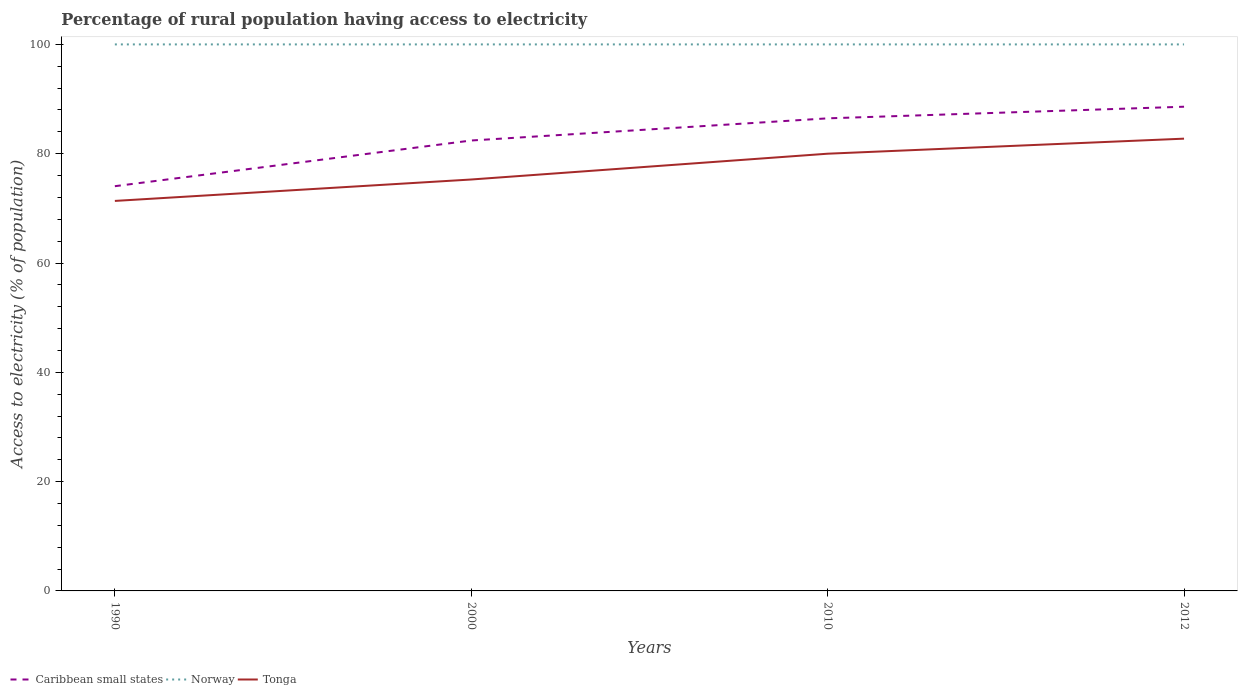Is the number of lines equal to the number of legend labels?
Ensure brevity in your answer.  Yes. Across all years, what is the maximum percentage of rural population having access to electricity in Norway?
Your answer should be very brief. 100. In which year was the percentage of rural population having access to electricity in Norway maximum?
Your response must be concise. 1990. What is the total percentage of rural population having access to electricity in Tonga in the graph?
Give a very brief answer. -2.75. What is the difference between the highest and the second highest percentage of rural population having access to electricity in Norway?
Offer a terse response. 0. What is the difference between the highest and the lowest percentage of rural population having access to electricity in Caribbean small states?
Ensure brevity in your answer.  2. Does the graph contain grids?
Give a very brief answer. No. How many legend labels are there?
Your response must be concise. 3. How are the legend labels stacked?
Provide a short and direct response. Horizontal. What is the title of the graph?
Offer a very short reply. Percentage of rural population having access to electricity. Does "Chad" appear as one of the legend labels in the graph?
Offer a terse response. No. What is the label or title of the Y-axis?
Your answer should be compact. Access to electricity (% of population). What is the Access to electricity (% of population) of Caribbean small states in 1990?
Offer a very short reply. 74.06. What is the Access to electricity (% of population) in Tonga in 1990?
Your answer should be very brief. 71.36. What is the Access to electricity (% of population) of Caribbean small states in 2000?
Your answer should be compact. 82.42. What is the Access to electricity (% of population) of Norway in 2000?
Provide a succinct answer. 100. What is the Access to electricity (% of population) in Tonga in 2000?
Your response must be concise. 75.28. What is the Access to electricity (% of population) of Caribbean small states in 2010?
Offer a terse response. 86.47. What is the Access to electricity (% of population) of Norway in 2010?
Your answer should be very brief. 100. What is the Access to electricity (% of population) of Caribbean small states in 2012?
Your answer should be very brief. 88.6. What is the Access to electricity (% of population) in Tonga in 2012?
Your answer should be compact. 82.75. Across all years, what is the maximum Access to electricity (% of population) in Caribbean small states?
Give a very brief answer. 88.6. Across all years, what is the maximum Access to electricity (% of population) of Norway?
Make the answer very short. 100. Across all years, what is the maximum Access to electricity (% of population) of Tonga?
Provide a succinct answer. 82.75. Across all years, what is the minimum Access to electricity (% of population) of Caribbean small states?
Your answer should be very brief. 74.06. Across all years, what is the minimum Access to electricity (% of population) of Norway?
Offer a terse response. 100. Across all years, what is the minimum Access to electricity (% of population) in Tonga?
Give a very brief answer. 71.36. What is the total Access to electricity (% of population) in Caribbean small states in the graph?
Provide a succinct answer. 331.54. What is the total Access to electricity (% of population) of Tonga in the graph?
Make the answer very short. 309.4. What is the difference between the Access to electricity (% of population) in Caribbean small states in 1990 and that in 2000?
Your answer should be very brief. -8.36. What is the difference between the Access to electricity (% of population) of Norway in 1990 and that in 2000?
Ensure brevity in your answer.  0. What is the difference between the Access to electricity (% of population) of Tonga in 1990 and that in 2000?
Ensure brevity in your answer.  -3.92. What is the difference between the Access to electricity (% of population) in Caribbean small states in 1990 and that in 2010?
Your answer should be very brief. -12.41. What is the difference between the Access to electricity (% of population) of Norway in 1990 and that in 2010?
Provide a short and direct response. 0. What is the difference between the Access to electricity (% of population) in Tonga in 1990 and that in 2010?
Ensure brevity in your answer.  -8.64. What is the difference between the Access to electricity (% of population) in Caribbean small states in 1990 and that in 2012?
Ensure brevity in your answer.  -14.54. What is the difference between the Access to electricity (% of population) in Norway in 1990 and that in 2012?
Offer a terse response. 0. What is the difference between the Access to electricity (% of population) of Tonga in 1990 and that in 2012?
Make the answer very short. -11.39. What is the difference between the Access to electricity (% of population) in Caribbean small states in 2000 and that in 2010?
Make the answer very short. -4.05. What is the difference between the Access to electricity (% of population) of Tonga in 2000 and that in 2010?
Provide a succinct answer. -4.72. What is the difference between the Access to electricity (% of population) of Caribbean small states in 2000 and that in 2012?
Provide a short and direct response. -6.18. What is the difference between the Access to electricity (% of population) of Tonga in 2000 and that in 2012?
Your answer should be very brief. -7.47. What is the difference between the Access to electricity (% of population) in Caribbean small states in 2010 and that in 2012?
Ensure brevity in your answer.  -2.13. What is the difference between the Access to electricity (% of population) in Tonga in 2010 and that in 2012?
Keep it short and to the point. -2.75. What is the difference between the Access to electricity (% of population) in Caribbean small states in 1990 and the Access to electricity (% of population) in Norway in 2000?
Offer a terse response. -25.94. What is the difference between the Access to electricity (% of population) in Caribbean small states in 1990 and the Access to electricity (% of population) in Tonga in 2000?
Keep it short and to the point. -1.22. What is the difference between the Access to electricity (% of population) in Norway in 1990 and the Access to electricity (% of population) in Tonga in 2000?
Ensure brevity in your answer.  24.72. What is the difference between the Access to electricity (% of population) of Caribbean small states in 1990 and the Access to electricity (% of population) of Norway in 2010?
Keep it short and to the point. -25.94. What is the difference between the Access to electricity (% of population) in Caribbean small states in 1990 and the Access to electricity (% of population) in Tonga in 2010?
Give a very brief answer. -5.94. What is the difference between the Access to electricity (% of population) in Caribbean small states in 1990 and the Access to electricity (% of population) in Norway in 2012?
Provide a short and direct response. -25.94. What is the difference between the Access to electricity (% of population) in Caribbean small states in 1990 and the Access to electricity (% of population) in Tonga in 2012?
Keep it short and to the point. -8.7. What is the difference between the Access to electricity (% of population) in Norway in 1990 and the Access to electricity (% of population) in Tonga in 2012?
Keep it short and to the point. 17.25. What is the difference between the Access to electricity (% of population) of Caribbean small states in 2000 and the Access to electricity (% of population) of Norway in 2010?
Your response must be concise. -17.58. What is the difference between the Access to electricity (% of population) of Caribbean small states in 2000 and the Access to electricity (% of population) of Tonga in 2010?
Your answer should be compact. 2.42. What is the difference between the Access to electricity (% of population) of Norway in 2000 and the Access to electricity (% of population) of Tonga in 2010?
Make the answer very short. 20. What is the difference between the Access to electricity (% of population) of Caribbean small states in 2000 and the Access to electricity (% of population) of Norway in 2012?
Offer a very short reply. -17.58. What is the difference between the Access to electricity (% of population) of Caribbean small states in 2000 and the Access to electricity (% of population) of Tonga in 2012?
Make the answer very short. -0.34. What is the difference between the Access to electricity (% of population) in Norway in 2000 and the Access to electricity (% of population) in Tonga in 2012?
Your answer should be very brief. 17.25. What is the difference between the Access to electricity (% of population) in Caribbean small states in 2010 and the Access to electricity (% of population) in Norway in 2012?
Make the answer very short. -13.53. What is the difference between the Access to electricity (% of population) in Caribbean small states in 2010 and the Access to electricity (% of population) in Tonga in 2012?
Your answer should be very brief. 3.72. What is the difference between the Access to electricity (% of population) in Norway in 2010 and the Access to electricity (% of population) in Tonga in 2012?
Provide a succinct answer. 17.25. What is the average Access to electricity (% of population) in Caribbean small states per year?
Offer a very short reply. 82.89. What is the average Access to electricity (% of population) of Tonga per year?
Provide a short and direct response. 77.35. In the year 1990, what is the difference between the Access to electricity (% of population) in Caribbean small states and Access to electricity (% of population) in Norway?
Provide a succinct answer. -25.94. In the year 1990, what is the difference between the Access to electricity (% of population) of Caribbean small states and Access to electricity (% of population) of Tonga?
Offer a very short reply. 2.7. In the year 1990, what is the difference between the Access to electricity (% of population) in Norway and Access to electricity (% of population) in Tonga?
Give a very brief answer. 28.64. In the year 2000, what is the difference between the Access to electricity (% of population) of Caribbean small states and Access to electricity (% of population) of Norway?
Your response must be concise. -17.58. In the year 2000, what is the difference between the Access to electricity (% of population) of Caribbean small states and Access to electricity (% of population) of Tonga?
Give a very brief answer. 7.14. In the year 2000, what is the difference between the Access to electricity (% of population) in Norway and Access to electricity (% of population) in Tonga?
Make the answer very short. 24.72. In the year 2010, what is the difference between the Access to electricity (% of population) in Caribbean small states and Access to electricity (% of population) in Norway?
Keep it short and to the point. -13.53. In the year 2010, what is the difference between the Access to electricity (% of population) in Caribbean small states and Access to electricity (% of population) in Tonga?
Keep it short and to the point. 6.47. In the year 2010, what is the difference between the Access to electricity (% of population) in Norway and Access to electricity (% of population) in Tonga?
Offer a terse response. 20. In the year 2012, what is the difference between the Access to electricity (% of population) in Caribbean small states and Access to electricity (% of population) in Norway?
Ensure brevity in your answer.  -11.4. In the year 2012, what is the difference between the Access to electricity (% of population) in Caribbean small states and Access to electricity (% of population) in Tonga?
Keep it short and to the point. 5.84. In the year 2012, what is the difference between the Access to electricity (% of population) in Norway and Access to electricity (% of population) in Tonga?
Your answer should be compact. 17.25. What is the ratio of the Access to electricity (% of population) of Caribbean small states in 1990 to that in 2000?
Offer a terse response. 0.9. What is the ratio of the Access to electricity (% of population) in Norway in 1990 to that in 2000?
Keep it short and to the point. 1. What is the ratio of the Access to electricity (% of population) of Tonga in 1990 to that in 2000?
Your response must be concise. 0.95. What is the ratio of the Access to electricity (% of population) of Caribbean small states in 1990 to that in 2010?
Ensure brevity in your answer.  0.86. What is the ratio of the Access to electricity (% of population) in Tonga in 1990 to that in 2010?
Your answer should be compact. 0.89. What is the ratio of the Access to electricity (% of population) in Caribbean small states in 1990 to that in 2012?
Give a very brief answer. 0.84. What is the ratio of the Access to electricity (% of population) in Norway in 1990 to that in 2012?
Ensure brevity in your answer.  1. What is the ratio of the Access to electricity (% of population) in Tonga in 1990 to that in 2012?
Provide a short and direct response. 0.86. What is the ratio of the Access to electricity (% of population) of Caribbean small states in 2000 to that in 2010?
Your response must be concise. 0.95. What is the ratio of the Access to electricity (% of population) in Tonga in 2000 to that in 2010?
Your response must be concise. 0.94. What is the ratio of the Access to electricity (% of population) of Caribbean small states in 2000 to that in 2012?
Your answer should be compact. 0.93. What is the ratio of the Access to electricity (% of population) in Tonga in 2000 to that in 2012?
Your response must be concise. 0.91. What is the ratio of the Access to electricity (% of population) of Norway in 2010 to that in 2012?
Provide a short and direct response. 1. What is the ratio of the Access to electricity (% of population) in Tonga in 2010 to that in 2012?
Make the answer very short. 0.97. What is the difference between the highest and the second highest Access to electricity (% of population) of Caribbean small states?
Offer a terse response. 2.13. What is the difference between the highest and the second highest Access to electricity (% of population) in Norway?
Offer a very short reply. 0. What is the difference between the highest and the second highest Access to electricity (% of population) in Tonga?
Ensure brevity in your answer.  2.75. What is the difference between the highest and the lowest Access to electricity (% of population) in Caribbean small states?
Provide a succinct answer. 14.54. What is the difference between the highest and the lowest Access to electricity (% of population) of Norway?
Ensure brevity in your answer.  0. What is the difference between the highest and the lowest Access to electricity (% of population) in Tonga?
Offer a very short reply. 11.39. 